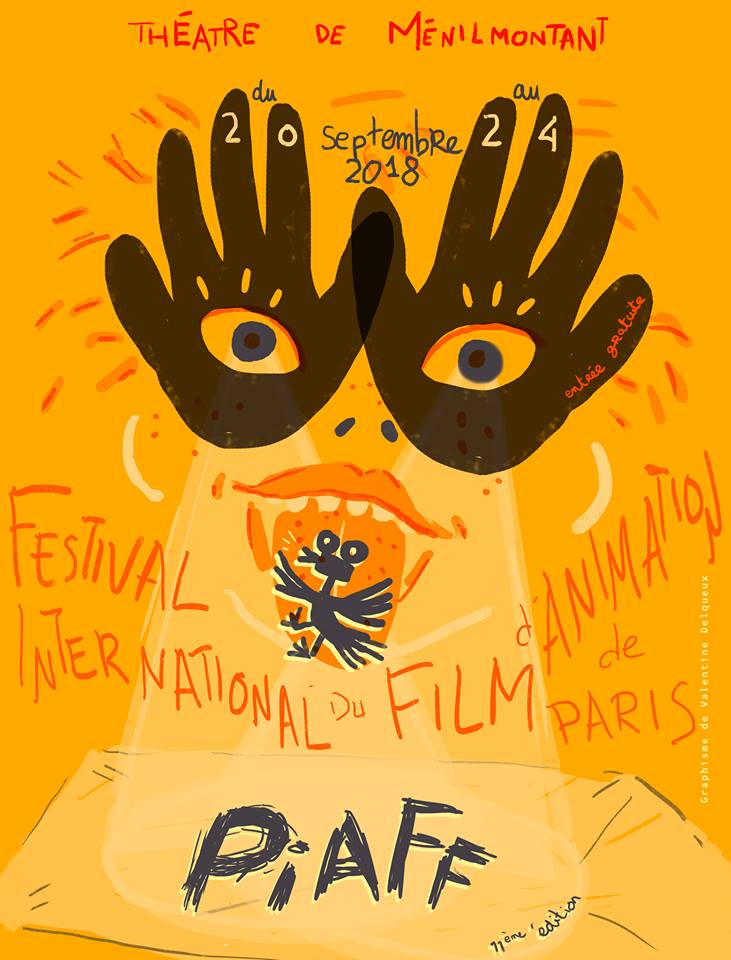Can you talk about the visual style of this poster? The visual style of the poster is striking and whimsical, characterized by vibrant, warm hues dominated by orange and yellow tones. The imagery includes hand-painted elements, such as the large, stylized hands with eyes, which give it a surreal and playful feel. This artistic choice aligns well with the theme of animation, evoking creativity and imagination. The typography is bold and varied, with a hand-drawn aesthetic that adds to the poster's informal and inviting vibe. Additionally, the playful character and expressive text reinforce the festival's dynamic, artistic nature. 